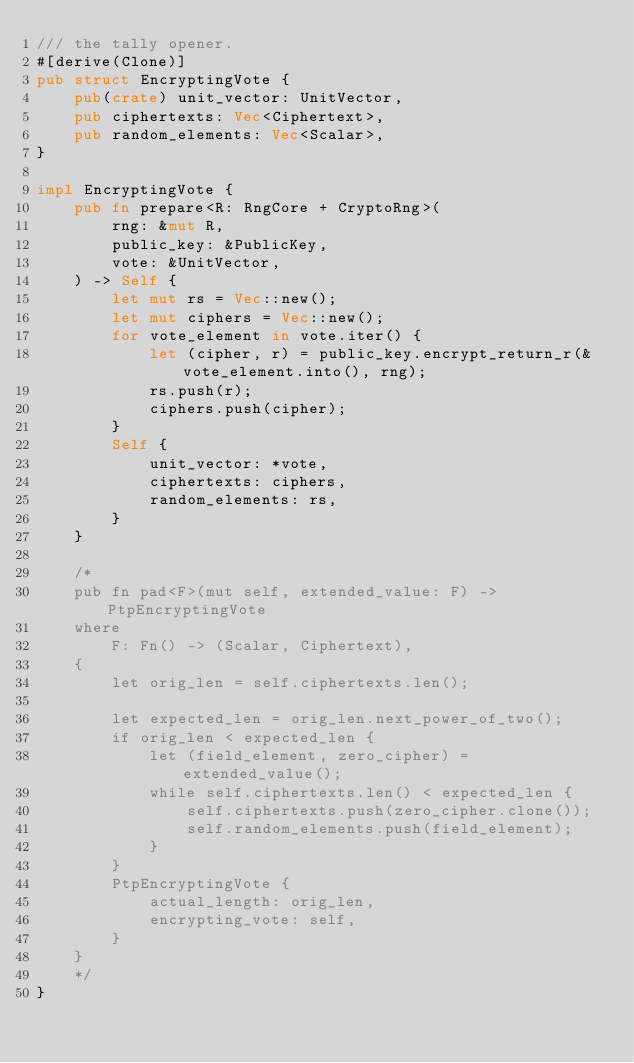<code> <loc_0><loc_0><loc_500><loc_500><_Rust_>/// the tally opener.
#[derive(Clone)]
pub struct EncryptingVote {
    pub(crate) unit_vector: UnitVector,
    pub ciphertexts: Vec<Ciphertext>,
    pub random_elements: Vec<Scalar>,
}

impl EncryptingVote {
    pub fn prepare<R: RngCore + CryptoRng>(
        rng: &mut R,
        public_key: &PublicKey,
        vote: &UnitVector,
    ) -> Self {
        let mut rs = Vec::new();
        let mut ciphers = Vec::new();
        for vote_element in vote.iter() {
            let (cipher, r) = public_key.encrypt_return_r(&vote_element.into(), rng);
            rs.push(r);
            ciphers.push(cipher);
        }
        Self {
            unit_vector: *vote,
            ciphertexts: ciphers,
            random_elements: rs,
        }
    }

    /*
    pub fn pad<F>(mut self, extended_value: F) -> PtpEncryptingVote
    where
        F: Fn() -> (Scalar, Ciphertext),
    {
        let orig_len = self.ciphertexts.len();

        let expected_len = orig_len.next_power_of_two();
        if orig_len < expected_len {
            let (field_element, zero_cipher) = extended_value();
            while self.ciphertexts.len() < expected_len {
                self.ciphertexts.push(zero_cipher.clone());
                self.random_elements.push(field_element);
            }
        }
        PtpEncryptingVote {
            actual_length: orig_len,
            encrypting_vote: self,
        }
    }
    */
}
</code> 